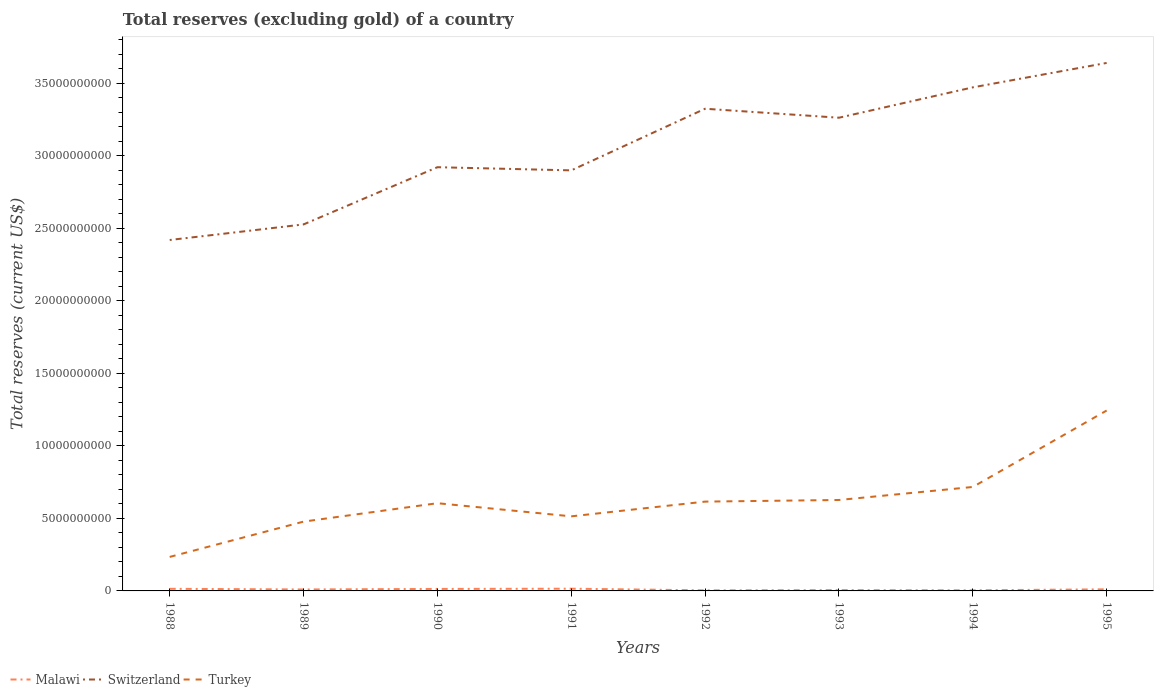How many different coloured lines are there?
Keep it short and to the point. 3. Does the line corresponding to Switzerland intersect with the line corresponding to Turkey?
Offer a very short reply. No. Is the number of lines equal to the number of legend labels?
Provide a short and direct response. Yes. Across all years, what is the maximum total reserves (excluding gold) in Malawi?
Provide a short and direct response. 3.99e+07. In which year was the total reserves (excluding gold) in Turkey maximum?
Offer a very short reply. 1988. What is the total total reserves (excluding gold) in Malawi in the graph?
Offer a very short reply. 9.72e+07. What is the difference between the highest and the second highest total reserves (excluding gold) in Switzerland?
Keep it short and to the point. 1.22e+1. Is the total reserves (excluding gold) in Turkey strictly greater than the total reserves (excluding gold) in Malawi over the years?
Ensure brevity in your answer.  No. Does the graph contain any zero values?
Ensure brevity in your answer.  No. Where does the legend appear in the graph?
Keep it short and to the point. Bottom left. What is the title of the graph?
Provide a succinct answer. Total reserves (excluding gold) of a country. Does "Netherlands" appear as one of the legend labels in the graph?
Offer a very short reply. No. What is the label or title of the Y-axis?
Keep it short and to the point. Total reserves (current US$). What is the Total reserves (current US$) in Malawi in 1988?
Your answer should be compact. 1.46e+08. What is the Total reserves (current US$) in Switzerland in 1988?
Make the answer very short. 2.42e+1. What is the Total reserves (current US$) of Turkey in 1988?
Offer a terse response. 2.34e+09. What is the Total reserves (current US$) in Malawi in 1989?
Provide a succinct answer. 1.00e+08. What is the Total reserves (current US$) in Switzerland in 1989?
Give a very brief answer. 2.53e+1. What is the Total reserves (current US$) in Turkey in 1989?
Keep it short and to the point. 4.78e+09. What is the Total reserves (current US$) of Malawi in 1990?
Offer a very short reply. 1.37e+08. What is the Total reserves (current US$) in Switzerland in 1990?
Your answer should be very brief. 2.92e+1. What is the Total reserves (current US$) in Turkey in 1990?
Keep it short and to the point. 6.05e+09. What is the Total reserves (current US$) of Malawi in 1991?
Give a very brief answer. 1.53e+08. What is the Total reserves (current US$) in Switzerland in 1991?
Keep it short and to the point. 2.90e+1. What is the Total reserves (current US$) of Turkey in 1991?
Your answer should be compact. 5.14e+09. What is the Total reserves (current US$) of Malawi in 1992?
Provide a succinct answer. 3.99e+07. What is the Total reserves (current US$) of Switzerland in 1992?
Your response must be concise. 3.33e+1. What is the Total reserves (current US$) of Turkey in 1992?
Provide a short and direct response. 6.16e+09. What is the Total reserves (current US$) of Malawi in 1993?
Provide a short and direct response. 5.69e+07. What is the Total reserves (current US$) in Switzerland in 1993?
Give a very brief answer. 3.26e+1. What is the Total reserves (current US$) in Turkey in 1993?
Your answer should be very brief. 6.27e+09. What is the Total reserves (current US$) of Malawi in 1994?
Ensure brevity in your answer.  4.28e+07. What is the Total reserves (current US$) in Switzerland in 1994?
Offer a terse response. 3.47e+1. What is the Total reserves (current US$) of Turkey in 1994?
Your response must be concise. 7.17e+09. What is the Total reserves (current US$) of Malawi in 1995?
Make the answer very short. 1.10e+08. What is the Total reserves (current US$) of Switzerland in 1995?
Your answer should be very brief. 3.64e+1. What is the Total reserves (current US$) in Turkey in 1995?
Give a very brief answer. 1.24e+1. Across all years, what is the maximum Total reserves (current US$) in Malawi?
Your answer should be very brief. 1.53e+08. Across all years, what is the maximum Total reserves (current US$) in Switzerland?
Offer a very short reply. 3.64e+1. Across all years, what is the maximum Total reserves (current US$) in Turkey?
Give a very brief answer. 1.24e+1. Across all years, what is the minimum Total reserves (current US$) of Malawi?
Keep it short and to the point. 3.99e+07. Across all years, what is the minimum Total reserves (current US$) of Switzerland?
Your response must be concise. 2.42e+1. Across all years, what is the minimum Total reserves (current US$) in Turkey?
Offer a very short reply. 2.34e+09. What is the total Total reserves (current US$) of Malawi in the graph?
Offer a very short reply. 7.86e+08. What is the total Total reserves (current US$) of Switzerland in the graph?
Ensure brevity in your answer.  2.45e+11. What is the total Total reserves (current US$) in Turkey in the graph?
Offer a very short reply. 5.04e+1. What is the difference between the Total reserves (current US$) of Malawi in 1988 and that in 1989?
Offer a terse response. 4.53e+07. What is the difference between the Total reserves (current US$) in Switzerland in 1988 and that in 1989?
Your answer should be very brief. -1.07e+09. What is the difference between the Total reserves (current US$) of Turkey in 1988 and that in 1989?
Your answer should be compact. -2.44e+09. What is the difference between the Total reserves (current US$) of Malawi in 1988 and that in 1990?
Your response must be concise. 8.41e+06. What is the difference between the Total reserves (current US$) of Switzerland in 1988 and that in 1990?
Your answer should be very brief. -5.02e+09. What is the difference between the Total reserves (current US$) of Turkey in 1988 and that in 1990?
Keep it short and to the point. -3.71e+09. What is the difference between the Total reserves (current US$) in Malawi in 1988 and that in 1991?
Your response must be concise. -7.63e+06. What is the difference between the Total reserves (current US$) in Switzerland in 1988 and that in 1991?
Give a very brief answer. -4.80e+09. What is the difference between the Total reserves (current US$) in Turkey in 1988 and that in 1991?
Your answer should be compact. -2.80e+09. What is the difference between the Total reserves (current US$) of Malawi in 1988 and that in 1992?
Provide a short and direct response. 1.06e+08. What is the difference between the Total reserves (current US$) of Switzerland in 1988 and that in 1992?
Your response must be concise. -9.05e+09. What is the difference between the Total reserves (current US$) in Turkey in 1988 and that in 1992?
Give a very brief answer. -3.81e+09. What is the difference between the Total reserves (current US$) in Malawi in 1988 and that in 1993?
Your response must be concise. 8.87e+07. What is the difference between the Total reserves (current US$) of Switzerland in 1988 and that in 1993?
Ensure brevity in your answer.  -8.43e+09. What is the difference between the Total reserves (current US$) in Turkey in 1988 and that in 1993?
Your answer should be compact. -3.93e+09. What is the difference between the Total reserves (current US$) in Malawi in 1988 and that in 1994?
Provide a short and direct response. 1.03e+08. What is the difference between the Total reserves (current US$) in Switzerland in 1988 and that in 1994?
Give a very brief answer. -1.05e+1. What is the difference between the Total reserves (current US$) in Turkey in 1988 and that in 1994?
Give a very brief answer. -4.82e+09. What is the difference between the Total reserves (current US$) of Malawi in 1988 and that in 1995?
Your answer should be very brief. 3.56e+07. What is the difference between the Total reserves (current US$) of Switzerland in 1988 and that in 1995?
Your answer should be very brief. -1.22e+1. What is the difference between the Total reserves (current US$) in Turkey in 1988 and that in 1995?
Your response must be concise. -1.01e+1. What is the difference between the Total reserves (current US$) of Malawi in 1989 and that in 1990?
Ensure brevity in your answer.  -3.68e+07. What is the difference between the Total reserves (current US$) of Switzerland in 1989 and that in 1990?
Your response must be concise. -3.95e+09. What is the difference between the Total reserves (current US$) in Turkey in 1989 and that in 1990?
Offer a very short reply. -1.27e+09. What is the difference between the Total reserves (current US$) in Malawi in 1989 and that in 1991?
Make the answer very short. -5.29e+07. What is the difference between the Total reserves (current US$) in Switzerland in 1989 and that in 1991?
Offer a very short reply. -3.73e+09. What is the difference between the Total reserves (current US$) of Turkey in 1989 and that in 1991?
Provide a succinct answer. -3.64e+08. What is the difference between the Total reserves (current US$) of Malawi in 1989 and that in 1992?
Offer a terse response. 6.04e+07. What is the difference between the Total reserves (current US$) in Switzerland in 1989 and that in 1992?
Provide a succinct answer. -7.98e+09. What is the difference between the Total reserves (current US$) of Turkey in 1989 and that in 1992?
Offer a very short reply. -1.38e+09. What is the difference between the Total reserves (current US$) of Malawi in 1989 and that in 1993?
Provide a succinct answer. 4.34e+07. What is the difference between the Total reserves (current US$) in Switzerland in 1989 and that in 1993?
Offer a terse response. -7.36e+09. What is the difference between the Total reserves (current US$) in Turkey in 1989 and that in 1993?
Give a very brief answer. -1.49e+09. What is the difference between the Total reserves (current US$) in Malawi in 1989 and that in 1994?
Ensure brevity in your answer.  5.75e+07. What is the difference between the Total reserves (current US$) in Switzerland in 1989 and that in 1994?
Give a very brief answer. -9.45e+09. What is the difference between the Total reserves (current US$) of Turkey in 1989 and that in 1994?
Keep it short and to the point. -2.39e+09. What is the difference between the Total reserves (current US$) in Malawi in 1989 and that in 1995?
Keep it short and to the point. -9.69e+06. What is the difference between the Total reserves (current US$) in Switzerland in 1989 and that in 1995?
Give a very brief answer. -1.11e+1. What is the difference between the Total reserves (current US$) of Turkey in 1989 and that in 1995?
Keep it short and to the point. -7.66e+09. What is the difference between the Total reserves (current US$) in Malawi in 1990 and that in 1991?
Keep it short and to the point. -1.60e+07. What is the difference between the Total reserves (current US$) in Switzerland in 1990 and that in 1991?
Keep it short and to the point. 2.19e+08. What is the difference between the Total reserves (current US$) in Turkey in 1990 and that in 1991?
Keep it short and to the point. 9.05e+08. What is the difference between the Total reserves (current US$) in Malawi in 1990 and that in 1992?
Provide a short and direct response. 9.72e+07. What is the difference between the Total reserves (current US$) of Switzerland in 1990 and that in 1992?
Ensure brevity in your answer.  -4.03e+09. What is the difference between the Total reserves (current US$) in Turkey in 1990 and that in 1992?
Provide a short and direct response. -1.10e+08. What is the difference between the Total reserves (current US$) in Malawi in 1990 and that in 1993?
Your answer should be very brief. 8.03e+07. What is the difference between the Total reserves (current US$) of Switzerland in 1990 and that in 1993?
Make the answer very short. -3.41e+09. What is the difference between the Total reserves (current US$) in Turkey in 1990 and that in 1993?
Offer a terse response. -2.22e+08. What is the difference between the Total reserves (current US$) of Malawi in 1990 and that in 1994?
Your answer should be very brief. 9.44e+07. What is the difference between the Total reserves (current US$) of Switzerland in 1990 and that in 1994?
Provide a succinct answer. -5.51e+09. What is the difference between the Total reserves (current US$) of Turkey in 1990 and that in 1994?
Offer a terse response. -1.12e+09. What is the difference between the Total reserves (current US$) of Malawi in 1990 and that in 1995?
Your response must be concise. 2.72e+07. What is the difference between the Total reserves (current US$) of Switzerland in 1990 and that in 1995?
Keep it short and to the point. -7.19e+09. What is the difference between the Total reserves (current US$) of Turkey in 1990 and that in 1995?
Make the answer very short. -6.39e+09. What is the difference between the Total reserves (current US$) in Malawi in 1991 and that in 1992?
Your response must be concise. 1.13e+08. What is the difference between the Total reserves (current US$) of Switzerland in 1991 and that in 1992?
Ensure brevity in your answer.  -4.25e+09. What is the difference between the Total reserves (current US$) of Turkey in 1991 and that in 1992?
Your answer should be compact. -1.02e+09. What is the difference between the Total reserves (current US$) of Malawi in 1991 and that in 1993?
Keep it short and to the point. 9.63e+07. What is the difference between the Total reserves (current US$) in Switzerland in 1991 and that in 1993?
Offer a very short reply. -3.63e+09. What is the difference between the Total reserves (current US$) of Turkey in 1991 and that in 1993?
Your response must be concise. -1.13e+09. What is the difference between the Total reserves (current US$) of Malawi in 1991 and that in 1994?
Your response must be concise. 1.10e+08. What is the difference between the Total reserves (current US$) of Switzerland in 1991 and that in 1994?
Provide a succinct answer. -5.73e+09. What is the difference between the Total reserves (current US$) of Turkey in 1991 and that in 1994?
Offer a very short reply. -2.03e+09. What is the difference between the Total reserves (current US$) of Malawi in 1991 and that in 1995?
Keep it short and to the point. 4.32e+07. What is the difference between the Total reserves (current US$) in Switzerland in 1991 and that in 1995?
Your answer should be very brief. -7.41e+09. What is the difference between the Total reserves (current US$) of Turkey in 1991 and that in 1995?
Offer a very short reply. -7.30e+09. What is the difference between the Total reserves (current US$) of Malawi in 1992 and that in 1993?
Provide a short and direct response. -1.69e+07. What is the difference between the Total reserves (current US$) in Switzerland in 1992 and that in 1993?
Your response must be concise. 6.20e+08. What is the difference between the Total reserves (current US$) of Turkey in 1992 and that in 1993?
Make the answer very short. -1.12e+08. What is the difference between the Total reserves (current US$) in Malawi in 1992 and that in 1994?
Make the answer very short. -2.85e+06. What is the difference between the Total reserves (current US$) of Switzerland in 1992 and that in 1994?
Your answer should be compact. -1.47e+09. What is the difference between the Total reserves (current US$) of Turkey in 1992 and that in 1994?
Offer a terse response. -1.01e+09. What is the difference between the Total reserves (current US$) of Malawi in 1992 and that in 1995?
Provide a succinct answer. -7.01e+07. What is the difference between the Total reserves (current US$) of Switzerland in 1992 and that in 1995?
Offer a very short reply. -3.16e+09. What is the difference between the Total reserves (current US$) of Turkey in 1992 and that in 1995?
Give a very brief answer. -6.28e+09. What is the difference between the Total reserves (current US$) of Malawi in 1993 and that in 1994?
Offer a very short reply. 1.41e+07. What is the difference between the Total reserves (current US$) in Switzerland in 1993 and that in 1994?
Make the answer very short. -2.09e+09. What is the difference between the Total reserves (current US$) of Turkey in 1993 and that in 1994?
Provide a short and direct response. -8.98e+08. What is the difference between the Total reserves (current US$) in Malawi in 1993 and that in 1995?
Provide a short and direct response. -5.31e+07. What is the difference between the Total reserves (current US$) in Switzerland in 1993 and that in 1995?
Provide a short and direct response. -3.78e+09. What is the difference between the Total reserves (current US$) of Turkey in 1993 and that in 1995?
Give a very brief answer. -6.17e+09. What is the difference between the Total reserves (current US$) of Malawi in 1994 and that in 1995?
Your response must be concise. -6.72e+07. What is the difference between the Total reserves (current US$) of Switzerland in 1994 and that in 1995?
Make the answer very short. -1.68e+09. What is the difference between the Total reserves (current US$) in Turkey in 1994 and that in 1995?
Make the answer very short. -5.27e+09. What is the difference between the Total reserves (current US$) in Malawi in 1988 and the Total reserves (current US$) in Switzerland in 1989?
Offer a very short reply. -2.51e+1. What is the difference between the Total reserves (current US$) in Malawi in 1988 and the Total reserves (current US$) in Turkey in 1989?
Ensure brevity in your answer.  -4.63e+09. What is the difference between the Total reserves (current US$) of Switzerland in 1988 and the Total reserves (current US$) of Turkey in 1989?
Offer a terse response. 1.94e+1. What is the difference between the Total reserves (current US$) of Malawi in 1988 and the Total reserves (current US$) of Switzerland in 1990?
Make the answer very short. -2.91e+1. What is the difference between the Total reserves (current US$) in Malawi in 1988 and the Total reserves (current US$) in Turkey in 1990?
Ensure brevity in your answer.  -5.90e+09. What is the difference between the Total reserves (current US$) in Switzerland in 1988 and the Total reserves (current US$) in Turkey in 1990?
Ensure brevity in your answer.  1.82e+1. What is the difference between the Total reserves (current US$) of Malawi in 1988 and the Total reserves (current US$) of Switzerland in 1991?
Your response must be concise. -2.89e+1. What is the difference between the Total reserves (current US$) in Malawi in 1988 and the Total reserves (current US$) in Turkey in 1991?
Provide a short and direct response. -5.00e+09. What is the difference between the Total reserves (current US$) in Switzerland in 1988 and the Total reserves (current US$) in Turkey in 1991?
Your answer should be compact. 1.91e+1. What is the difference between the Total reserves (current US$) in Malawi in 1988 and the Total reserves (current US$) in Switzerland in 1992?
Give a very brief answer. -3.31e+1. What is the difference between the Total reserves (current US$) in Malawi in 1988 and the Total reserves (current US$) in Turkey in 1992?
Give a very brief answer. -6.01e+09. What is the difference between the Total reserves (current US$) in Switzerland in 1988 and the Total reserves (current US$) in Turkey in 1992?
Provide a succinct answer. 1.80e+1. What is the difference between the Total reserves (current US$) in Malawi in 1988 and the Total reserves (current US$) in Switzerland in 1993?
Give a very brief answer. -3.25e+1. What is the difference between the Total reserves (current US$) of Malawi in 1988 and the Total reserves (current US$) of Turkey in 1993?
Keep it short and to the point. -6.13e+09. What is the difference between the Total reserves (current US$) of Switzerland in 1988 and the Total reserves (current US$) of Turkey in 1993?
Make the answer very short. 1.79e+1. What is the difference between the Total reserves (current US$) of Malawi in 1988 and the Total reserves (current US$) of Switzerland in 1994?
Your answer should be very brief. -3.46e+1. What is the difference between the Total reserves (current US$) in Malawi in 1988 and the Total reserves (current US$) in Turkey in 1994?
Offer a very short reply. -7.02e+09. What is the difference between the Total reserves (current US$) of Switzerland in 1988 and the Total reserves (current US$) of Turkey in 1994?
Your answer should be very brief. 1.70e+1. What is the difference between the Total reserves (current US$) in Malawi in 1988 and the Total reserves (current US$) in Switzerland in 1995?
Ensure brevity in your answer.  -3.63e+1. What is the difference between the Total reserves (current US$) in Malawi in 1988 and the Total reserves (current US$) in Turkey in 1995?
Ensure brevity in your answer.  -1.23e+1. What is the difference between the Total reserves (current US$) in Switzerland in 1988 and the Total reserves (current US$) in Turkey in 1995?
Offer a very short reply. 1.18e+1. What is the difference between the Total reserves (current US$) of Malawi in 1989 and the Total reserves (current US$) of Switzerland in 1990?
Keep it short and to the point. -2.91e+1. What is the difference between the Total reserves (current US$) of Malawi in 1989 and the Total reserves (current US$) of Turkey in 1990?
Make the answer very short. -5.95e+09. What is the difference between the Total reserves (current US$) in Switzerland in 1989 and the Total reserves (current US$) in Turkey in 1990?
Provide a short and direct response. 1.92e+1. What is the difference between the Total reserves (current US$) in Malawi in 1989 and the Total reserves (current US$) in Switzerland in 1991?
Ensure brevity in your answer.  -2.89e+1. What is the difference between the Total reserves (current US$) of Malawi in 1989 and the Total reserves (current US$) of Turkey in 1991?
Make the answer very short. -5.04e+09. What is the difference between the Total reserves (current US$) of Switzerland in 1989 and the Total reserves (current US$) of Turkey in 1991?
Provide a succinct answer. 2.01e+1. What is the difference between the Total reserves (current US$) in Malawi in 1989 and the Total reserves (current US$) in Switzerland in 1992?
Make the answer very short. -3.32e+1. What is the difference between the Total reserves (current US$) in Malawi in 1989 and the Total reserves (current US$) in Turkey in 1992?
Provide a short and direct response. -6.06e+09. What is the difference between the Total reserves (current US$) in Switzerland in 1989 and the Total reserves (current US$) in Turkey in 1992?
Ensure brevity in your answer.  1.91e+1. What is the difference between the Total reserves (current US$) in Malawi in 1989 and the Total reserves (current US$) in Switzerland in 1993?
Provide a short and direct response. -3.25e+1. What is the difference between the Total reserves (current US$) in Malawi in 1989 and the Total reserves (current US$) in Turkey in 1993?
Make the answer very short. -6.17e+09. What is the difference between the Total reserves (current US$) of Switzerland in 1989 and the Total reserves (current US$) of Turkey in 1993?
Give a very brief answer. 1.90e+1. What is the difference between the Total reserves (current US$) in Malawi in 1989 and the Total reserves (current US$) in Switzerland in 1994?
Keep it short and to the point. -3.46e+1. What is the difference between the Total reserves (current US$) in Malawi in 1989 and the Total reserves (current US$) in Turkey in 1994?
Your response must be concise. -7.07e+09. What is the difference between the Total reserves (current US$) of Switzerland in 1989 and the Total reserves (current US$) of Turkey in 1994?
Ensure brevity in your answer.  1.81e+1. What is the difference between the Total reserves (current US$) in Malawi in 1989 and the Total reserves (current US$) in Switzerland in 1995?
Give a very brief answer. -3.63e+1. What is the difference between the Total reserves (current US$) in Malawi in 1989 and the Total reserves (current US$) in Turkey in 1995?
Your response must be concise. -1.23e+1. What is the difference between the Total reserves (current US$) in Switzerland in 1989 and the Total reserves (current US$) in Turkey in 1995?
Keep it short and to the point. 1.28e+1. What is the difference between the Total reserves (current US$) in Malawi in 1990 and the Total reserves (current US$) in Switzerland in 1991?
Offer a very short reply. -2.89e+1. What is the difference between the Total reserves (current US$) in Malawi in 1990 and the Total reserves (current US$) in Turkey in 1991?
Keep it short and to the point. -5.01e+09. What is the difference between the Total reserves (current US$) of Switzerland in 1990 and the Total reserves (current US$) of Turkey in 1991?
Provide a short and direct response. 2.41e+1. What is the difference between the Total reserves (current US$) of Malawi in 1990 and the Total reserves (current US$) of Switzerland in 1992?
Your response must be concise. -3.31e+1. What is the difference between the Total reserves (current US$) of Malawi in 1990 and the Total reserves (current US$) of Turkey in 1992?
Offer a very short reply. -6.02e+09. What is the difference between the Total reserves (current US$) in Switzerland in 1990 and the Total reserves (current US$) in Turkey in 1992?
Ensure brevity in your answer.  2.31e+1. What is the difference between the Total reserves (current US$) of Malawi in 1990 and the Total reserves (current US$) of Switzerland in 1993?
Your answer should be very brief. -3.25e+1. What is the difference between the Total reserves (current US$) of Malawi in 1990 and the Total reserves (current US$) of Turkey in 1993?
Offer a terse response. -6.13e+09. What is the difference between the Total reserves (current US$) in Switzerland in 1990 and the Total reserves (current US$) in Turkey in 1993?
Offer a terse response. 2.30e+1. What is the difference between the Total reserves (current US$) in Malawi in 1990 and the Total reserves (current US$) in Switzerland in 1994?
Your answer should be very brief. -3.46e+1. What is the difference between the Total reserves (current US$) in Malawi in 1990 and the Total reserves (current US$) in Turkey in 1994?
Provide a short and direct response. -7.03e+09. What is the difference between the Total reserves (current US$) of Switzerland in 1990 and the Total reserves (current US$) of Turkey in 1994?
Provide a succinct answer. 2.21e+1. What is the difference between the Total reserves (current US$) in Malawi in 1990 and the Total reserves (current US$) in Switzerland in 1995?
Offer a terse response. -3.63e+1. What is the difference between the Total reserves (current US$) of Malawi in 1990 and the Total reserves (current US$) of Turkey in 1995?
Your answer should be compact. -1.23e+1. What is the difference between the Total reserves (current US$) in Switzerland in 1990 and the Total reserves (current US$) in Turkey in 1995?
Keep it short and to the point. 1.68e+1. What is the difference between the Total reserves (current US$) of Malawi in 1991 and the Total reserves (current US$) of Switzerland in 1992?
Provide a short and direct response. -3.31e+1. What is the difference between the Total reserves (current US$) in Malawi in 1991 and the Total reserves (current US$) in Turkey in 1992?
Offer a very short reply. -6.01e+09. What is the difference between the Total reserves (current US$) of Switzerland in 1991 and the Total reserves (current US$) of Turkey in 1992?
Give a very brief answer. 2.28e+1. What is the difference between the Total reserves (current US$) of Malawi in 1991 and the Total reserves (current US$) of Switzerland in 1993?
Offer a very short reply. -3.25e+1. What is the difference between the Total reserves (current US$) in Malawi in 1991 and the Total reserves (current US$) in Turkey in 1993?
Make the answer very short. -6.12e+09. What is the difference between the Total reserves (current US$) in Switzerland in 1991 and the Total reserves (current US$) in Turkey in 1993?
Offer a very short reply. 2.27e+1. What is the difference between the Total reserves (current US$) in Malawi in 1991 and the Total reserves (current US$) in Switzerland in 1994?
Your response must be concise. -3.46e+1. What is the difference between the Total reserves (current US$) in Malawi in 1991 and the Total reserves (current US$) in Turkey in 1994?
Provide a short and direct response. -7.02e+09. What is the difference between the Total reserves (current US$) of Switzerland in 1991 and the Total reserves (current US$) of Turkey in 1994?
Your answer should be very brief. 2.18e+1. What is the difference between the Total reserves (current US$) of Malawi in 1991 and the Total reserves (current US$) of Switzerland in 1995?
Ensure brevity in your answer.  -3.63e+1. What is the difference between the Total reserves (current US$) in Malawi in 1991 and the Total reserves (current US$) in Turkey in 1995?
Offer a very short reply. -1.23e+1. What is the difference between the Total reserves (current US$) of Switzerland in 1991 and the Total reserves (current US$) of Turkey in 1995?
Ensure brevity in your answer.  1.66e+1. What is the difference between the Total reserves (current US$) of Malawi in 1992 and the Total reserves (current US$) of Switzerland in 1993?
Offer a terse response. -3.26e+1. What is the difference between the Total reserves (current US$) of Malawi in 1992 and the Total reserves (current US$) of Turkey in 1993?
Make the answer very short. -6.23e+09. What is the difference between the Total reserves (current US$) in Switzerland in 1992 and the Total reserves (current US$) in Turkey in 1993?
Your response must be concise. 2.70e+1. What is the difference between the Total reserves (current US$) in Malawi in 1992 and the Total reserves (current US$) in Switzerland in 1994?
Provide a short and direct response. -3.47e+1. What is the difference between the Total reserves (current US$) in Malawi in 1992 and the Total reserves (current US$) in Turkey in 1994?
Give a very brief answer. -7.13e+09. What is the difference between the Total reserves (current US$) of Switzerland in 1992 and the Total reserves (current US$) of Turkey in 1994?
Keep it short and to the point. 2.61e+1. What is the difference between the Total reserves (current US$) of Malawi in 1992 and the Total reserves (current US$) of Switzerland in 1995?
Your answer should be compact. -3.64e+1. What is the difference between the Total reserves (current US$) in Malawi in 1992 and the Total reserves (current US$) in Turkey in 1995?
Make the answer very short. -1.24e+1. What is the difference between the Total reserves (current US$) in Switzerland in 1992 and the Total reserves (current US$) in Turkey in 1995?
Offer a terse response. 2.08e+1. What is the difference between the Total reserves (current US$) in Malawi in 1993 and the Total reserves (current US$) in Switzerland in 1994?
Your response must be concise. -3.47e+1. What is the difference between the Total reserves (current US$) in Malawi in 1993 and the Total reserves (current US$) in Turkey in 1994?
Provide a succinct answer. -7.11e+09. What is the difference between the Total reserves (current US$) in Switzerland in 1993 and the Total reserves (current US$) in Turkey in 1994?
Your answer should be compact. 2.55e+1. What is the difference between the Total reserves (current US$) in Malawi in 1993 and the Total reserves (current US$) in Switzerland in 1995?
Your response must be concise. -3.64e+1. What is the difference between the Total reserves (current US$) of Malawi in 1993 and the Total reserves (current US$) of Turkey in 1995?
Provide a short and direct response. -1.24e+1. What is the difference between the Total reserves (current US$) of Switzerland in 1993 and the Total reserves (current US$) of Turkey in 1995?
Keep it short and to the point. 2.02e+1. What is the difference between the Total reserves (current US$) of Malawi in 1994 and the Total reserves (current US$) of Switzerland in 1995?
Your answer should be compact. -3.64e+1. What is the difference between the Total reserves (current US$) of Malawi in 1994 and the Total reserves (current US$) of Turkey in 1995?
Give a very brief answer. -1.24e+1. What is the difference between the Total reserves (current US$) in Switzerland in 1994 and the Total reserves (current US$) in Turkey in 1995?
Offer a terse response. 2.23e+1. What is the average Total reserves (current US$) in Malawi per year?
Offer a very short reply. 9.82e+07. What is the average Total reserves (current US$) in Switzerland per year?
Give a very brief answer. 3.06e+1. What is the average Total reserves (current US$) of Turkey per year?
Ensure brevity in your answer.  6.30e+09. In the year 1988, what is the difference between the Total reserves (current US$) of Malawi and Total reserves (current US$) of Switzerland?
Keep it short and to the point. -2.41e+1. In the year 1988, what is the difference between the Total reserves (current US$) of Malawi and Total reserves (current US$) of Turkey?
Offer a terse response. -2.20e+09. In the year 1988, what is the difference between the Total reserves (current US$) in Switzerland and Total reserves (current US$) in Turkey?
Provide a succinct answer. 2.19e+1. In the year 1989, what is the difference between the Total reserves (current US$) of Malawi and Total reserves (current US$) of Switzerland?
Offer a very short reply. -2.52e+1. In the year 1989, what is the difference between the Total reserves (current US$) in Malawi and Total reserves (current US$) in Turkey?
Your response must be concise. -4.68e+09. In the year 1989, what is the difference between the Total reserves (current US$) in Switzerland and Total reserves (current US$) in Turkey?
Provide a succinct answer. 2.05e+1. In the year 1990, what is the difference between the Total reserves (current US$) of Malawi and Total reserves (current US$) of Switzerland?
Give a very brief answer. -2.91e+1. In the year 1990, what is the difference between the Total reserves (current US$) of Malawi and Total reserves (current US$) of Turkey?
Keep it short and to the point. -5.91e+09. In the year 1990, what is the difference between the Total reserves (current US$) of Switzerland and Total reserves (current US$) of Turkey?
Your answer should be compact. 2.32e+1. In the year 1991, what is the difference between the Total reserves (current US$) in Malawi and Total reserves (current US$) in Switzerland?
Your response must be concise. -2.89e+1. In the year 1991, what is the difference between the Total reserves (current US$) in Malawi and Total reserves (current US$) in Turkey?
Offer a terse response. -4.99e+09. In the year 1991, what is the difference between the Total reserves (current US$) in Switzerland and Total reserves (current US$) in Turkey?
Your answer should be very brief. 2.39e+1. In the year 1992, what is the difference between the Total reserves (current US$) in Malawi and Total reserves (current US$) in Switzerland?
Your answer should be compact. -3.32e+1. In the year 1992, what is the difference between the Total reserves (current US$) in Malawi and Total reserves (current US$) in Turkey?
Give a very brief answer. -6.12e+09. In the year 1992, what is the difference between the Total reserves (current US$) in Switzerland and Total reserves (current US$) in Turkey?
Provide a succinct answer. 2.71e+1. In the year 1993, what is the difference between the Total reserves (current US$) of Malawi and Total reserves (current US$) of Switzerland?
Offer a terse response. -3.26e+1. In the year 1993, what is the difference between the Total reserves (current US$) in Malawi and Total reserves (current US$) in Turkey?
Offer a terse response. -6.21e+09. In the year 1993, what is the difference between the Total reserves (current US$) of Switzerland and Total reserves (current US$) of Turkey?
Keep it short and to the point. 2.64e+1. In the year 1994, what is the difference between the Total reserves (current US$) of Malawi and Total reserves (current US$) of Switzerland?
Keep it short and to the point. -3.47e+1. In the year 1994, what is the difference between the Total reserves (current US$) of Malawi and Total reserves (current US$) of Turkey?
Provide a short and direct response. -7.13e+09. In the year 1994, what is the difference between the Total reserves (current US$) in Switzerland and Total reserves (current US$) in Turkey?
Your answer should be compact. 2.76e+1. In the year 1995, what is the difference between the Total reserves (current US$) in Malawi and Total reserves (current US$) in Switzerland?
Provide a succinct answer. -3.63e+1. In the year 1995, what is the difference between the Total reserves (current US$) of Malawi and Total reserves (current US$) of Turkey?
Offer a very short reply. -1.23e+1. In the year 1995, what is the difference between the Total reserves (current US$) of Switzerland and Total reserves (current US$) of Turkey?
Provide a succinct answer. 2.40e+1. What is the ratio of the Total reserves (current US$) in Malawi in 1988 to that in 1989?
Your response must be concise. 1.45. What is the ratio of the Total reserves (current US$) of Switzerland in 1988 to that in 1989?
Provide a succinct answer. 0.96. What is the ratio of the Total reserves (current US$) of Turkey in 1988 to that in 1989?
Your response must be concise. 0.49. What is the ratio of the Total reserves (current US$) in Malawi in 1988 to that in 1990?
Give a very brief answer. 1.06. What is the ratio of the Total reserves (current US$) in Switzerland in 1988 to that in 1990?
Provide a short and direct response. 0.83. What is the ratio of the Total reserves (current US$) in Turkey in 1988 to that in 1990?
Your response must be concise. 0.39. What is the ratio of the Total reserves (current US$) in Malawi in 1988 to that in 1991?
Provide a short and direct response. 0.95. What is the ratio of the Total reserves (current US$) of Switzerland in 1988 to that in 1991?
Keep it short and to the point. 0.83. What is the ratio of the Total reserves (current US$) in Turkey in 1988 to that in 1991?
Give a very brief answer. 0.46. What is the ratio of the Total reserves (current US$) in Malawi in 1988 to that in 1992?
Make the answer very short. 3.64. What is the ratio of the Total reserves (current US$) in Switzerland in 1988 to that in 1992?
Your response must be concise. 0.73. What is the ratio of the Total reserves (current US$) of Turkey in 1988 to that in 1992?
Make the answer very short. 0.38. What is the ratio of the Total reserves (current US$) of Malawi in 1988 to that in 1993?
Your response must be concise. 2.56. What is the ratio of the Total reserves (current US$) in Switzerland in 1988 to that in 1993?
Offer a very short reply. 0.74. What is the ratio of the Total reserves (current US$) of Turkey in 1988 to that in 1993?
Your answer should be very brief. 0.37. What is the ratio of the Total reserves (current US$) in Malawi in 1988 to that in 1994?
Your answer should be very brief. 3.4. What is the ratio of the Total reserves (current US$) in Switzerland in 1988 to that in 1994?
Offer a very short reply. 0.7. What is the ratio of the Total reserves (current US$) of Turkey in 1988 to that in 1994?
Provide a short and direct response. 0.33. What is the ratio of the Total reserves (current US$) of Malawi in 1988 to that in 1995?
Your answer should be very brief. 1.32. What is the ratio of the Total reserves (current US$) of Switzerland in 1988 to that in 1995?
Provide a short and direct response. 0.66. What is the ratio of the Total reserves (current US$) of Turkey in 1988 to that in 1995?
Ensure brevity in your answer.  0.19. What is the ratio of the Total reserves (current US$) of Malawi in 1989 to that in 1990?
Give a very brief answer. 0.73. What is the ratio of the Total reserves (current US$) of Switzerland in 1989 to that in 1990?
Offer a terse response. 0.86. What is the ratio of the Total reserves (current US$) of Turkey in 1989 to that in 1990?
Your response must be concise. 0.79. What is the ratio of the Total reserves (current US$) in Malawi in 1989 to that in 1991?
Your answer should be very brief. 0.65. What is the ratio of the Total reserves (current US$) in Switzerland in 1989 to that in 1991?
Give a very brief answer. 0.87. What is the ratio of the Total reserves (current US$) in Turkey in 1989 to that in 1991?
Make the answer very short. 0.93. What is the ratio of the Total reserves (current US$) of Malawi in 1989 to that in 1992?
Your answer should be compact. 2.51. What is the ratio of the Total reserves (current US$) in Switzerland in 1989 to that in 1992?
Keep it short and to the point. 0.76. What is the ratio of the Total reserves (current US$) in Turkey in 1989 to that in 1992?
Your response must be concise. 0.78. What is the ratio of the Total reserves (current US$) of Malawi in 1989 to that in 1993?
Your answer should be very brief. 1.76. What is the ratio of the Total reserves (current US$) in Switzerland in 1989 to that in 1993?
Provide a short and direct response. 0.77. What is the ratio of the Total reserves (current US$) of Turkey in 1989 to that in 1993?
Offer a very short reply. 0.76. What is the ratio of the Total reserves (current US$) in Malawi in 1989 to that in 1994?
Give a very brief answer. 2.34. What is the ratio of the Total reserves (current US$) in Switzerland in 1989 to that in 1994?
Keep it short and to the point. 0.73. What is the ratio of the Total reserves (current US$) of Turkey in 1989 to that in 1994?
Ensure brevity in your answer.  0.67. What is the ratio of the Total reserves (current US$) of Malawi in 1989 to that in 1995?
Your answer should be very brief. 0.91. What is the ratio of the Total reserves (current US$) of Switzerland in 1989 to that in 1995?
Give a very brief answer. 0.69. What is the ratio of the Total reserves (current US$) in Turkey in 1989 to that in 1995?
Your answer should be very brief. 0.38. What is the ratio of the Total reserves (current US$) of Malawi in 1990 to that in 1991?
Your response must be concise. 0.9. What is the ratio of the Total reserves (current US$) in Switzerland in 1990 to that in 1991?
Ensure brevity in your answer.  1.01. What is the ratio of the Total reserves (current US$) of Turkey in 1990 to that in 1991?
Give a very brief answer. 1.18. What is the ratio of the Total reserves (current US$) in Malawi in 1990 to that in 1992?
Your response must be concise. 3.43. What is the ratio of the Total reserves (current US$) in Switzerland in 1990 to that in 1992?
Provide a short and direct response. 0.88. What is the ratio of the Total reserves (current US$) in Turkey in 1990 to that in 1992?
Make the answer very short. 0.98. What is the ratio of the Total reserves (current US$) of Malawi in 1990 to that in 1993?
Make the answer very short. 2.41. What is the ratio of the Total reserves (current US$) in Switzerland in 1990 to that in 1993?
Give a very brief answer. 0.9. What is the ratio of the Total reserves (current US$) of Turkey in 1990 to that in 1993?
Your response must be concise. 0.96. What is the ratio of the Total reserves (current US$) in Malawi in 1990 to that in 1994?
Give a very brief answer. 3.2. What is the ratio of the Total reserves (current US$) in Switzerland in 1990 to that in 1994?
Make the answer very short. 0.84. What is the ratio of the Total reserves (current US$) of Turkey in 1990 to that in 1994?
Give a very brief answer. 0.84. What is the ratio of the Total reserves (current US$) of Malawi in 1990 to that in 1995?
Offer a very short reply. 1.25. What is the ratio of the Total reserves (current US$) of Switzerland in 1990 to that in 1995?
Make the answer very short. 0.8. What is the ratio of the Total reserves (current US$) in Turkey in 1990 to that in 1995?
Your answer should be compact. 0.49. What is the ratio of the Total reserves (current US$) of Malawi in 1991 to that in 1992?
Offer a terse response. 3.83. What is the ratio of the Total reserves (current US$) in Switzerland in 1991 to that in 1992?
Your response must be concise. 0.87. What is the ratio of the Total reserves (current US$) in Turkey in 1991 to that in 1992?
Your answer should be compact. 0.84. What is the ratio of the Total reserves (current US$) in Malawi in 1991 to that in 1993?
Offer a very short reply. 2.69. What is the ratio of the Total reserves (current US$) in Switzerland in 1991 to that in 1993?
Keep it short and to the point. 0.89. What is the ratio of the Total reserves (current US$) in Turkey in 1991 to that in 1993?
Ensure brevity in your answer.  0.82. What is the ratio of the Total reserves (current US$) of Malawi in 1991 to that in 1994?
Offer a very short reply. 3.58. What is the ratio of the Total reserves (current US$) of Switzerland in 1991 to that in 1994?
Keep it short and to the point. 0.84. What is the ratio of the Total reserves (current US$) of Turkey in 1991 to that in 1994?
Ensure brevity in your answer.  0.72. What is the ratio of the Total reserves (current US$) of Malawi in 1991 to that in 1995?
Offer a very short reply. 1.39. What is the ratio of the Total reserves (current US$) of Switzerland in 1991 to that in 1995?
Offer a very short reply. 0.8. What is the ratio of the Total reserves (current US$) of Turkey in 1991 to that in 1995?
Your response must be concise. 0.41. What is the ratio of the Total reserves (current US$) of Malawi in 1992 to that in 1993?
Offer a very short reply. 0.7. What is the ratio of the Total reserves (current US$) in Turkey in 1992 to that in 1993?
Provide a short and direct response. 0.98. What is the ratio of the Total reserves (current US$) in Malawi in 1992 to that in 1994?
Provide a succinct answer. 0.93. What is the ratio of the Total reserves (current US$) of Switzerland in 1992 to that in 1994?
Keep it short and to the point. 0.96. What is the ratio of the Total reserves (current US$) of Turkey in 1992 to that in 1994?
Your answer should be very brief. 0.86. What is the ratio of the Total reserves (current US$) in Malawi in 1992 to that in 1995?
Ensure brevity in your answer.  0.36. What is the ratio of the Total reserves (current US$) of Switzerland in 1992 to that in 1995?
Your answer should be very brief. 0.91. What is the ratio of the Total reserves (current US$) of Turkey in 1992 to that in 1995?
Your answer should be compact. 0.5. What is the ratio of the Total reserves (current US$) of Malawi in 1993 to that in 1994?
Your response must be concise. 1.33. What is the ratio of the Total reserves (current US$) in Switzerland in 1993 to that in 1994?
Provide a short and direct response. 0.94. What is the ratio of the Total reserves (current US$) of Turkey in 1993 to that in 1994?
Make the answer very short. 0.87. What is the ratio of the Total reserves (current US$) of Malawi in 1993 to that in 1995?
Make the answer very short. 0.52. What is the ratio of the Total reserves (current US$) in Switzerland in 1993 to that in 1995?
Provide a short and direct response. 0.9. What is the ratio of the Total reserves (current US$) of Turkey in 1993 to that in 1995?
Give a very brief answer. 0.5. What is the ratio of the Total reserves (current US$) in Malawi in 1994 to that in 1995?
Your answer should be very brief. 0.39. What is the ratio of the Total reserves (current US$) in Switzerland in 1994 to that in 1995?
Offer a very short reply. 0.95. What is the ratio of the Total reserves (current US$) in Turkey in 1994 to that in 1995?
Ensure brevity in your answer.  0.58. What is the difference between the highest and the second highest Total reserves (current US$) of Malawi?
Your answer should be very brief. 7.63e+06. What is the difference between the highest and the second highest Total reserves (current US$) in Switzerland?
Give a very brief answer. 1.68e+09. What is the difference between the highest and the second highest Total reserves (current US$) of Turkey?
Offer a terse response. 5.27e+09. What is the difference between the highest and the lowest Total reserves (current US$) of Malawi?
Offer a very short reply. 1.13e+08. What is the difference between the highest and the lowest Total reserves (current US$) of Switzerland?
Provide a short and direct response. 1.22e+1. What is the difference between the highest and the lowest Total reserves (current US$) of Turkey?
Offer a terse response. 1.01e+1. 